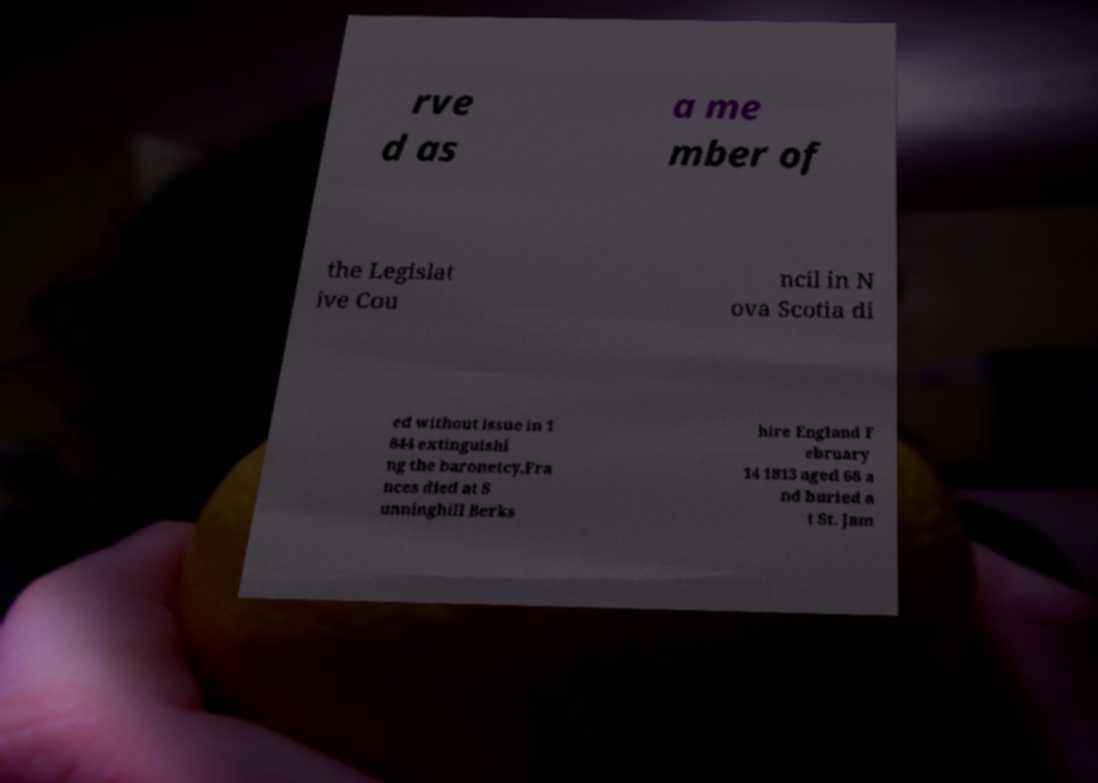Could you assist in decoding the text presented in this image and type it out clearly? rve d as a me mber of the Legislat ive Cou ncil in N ova Scotia di ed without issue in 1 844 extinguishi ng the baronetcy.Fra nces died at S unninghill Berks hire England F ebruary 14 1813 aged 68 a nd buried a t St. Jam 